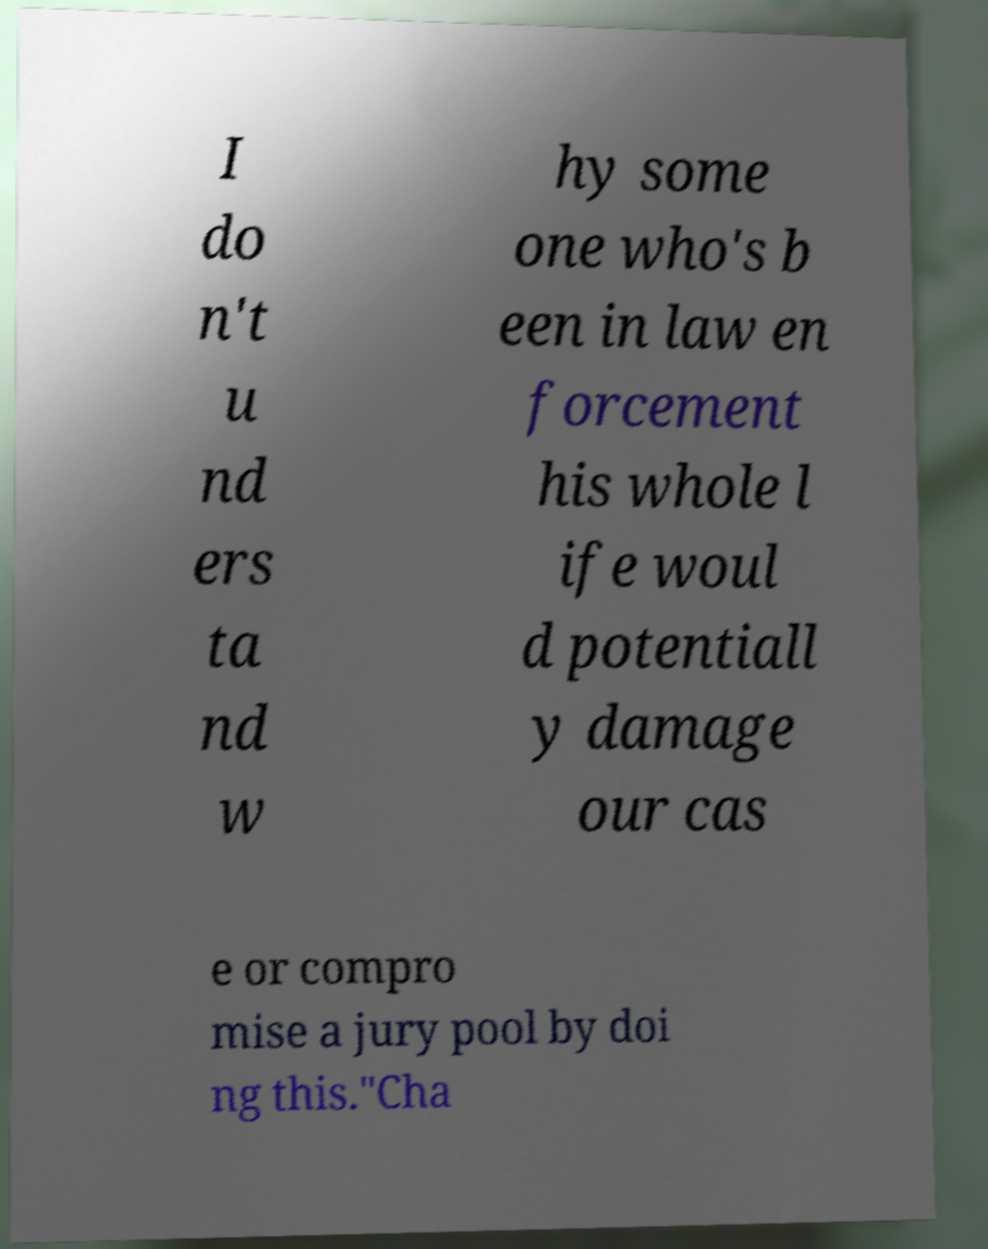I need the written content from this picture converted into text. Can you do that? I do n't u nd ers ta nd w hy some one who's b een in law en forcement his whole l ife woul d potentiall y damage our cas e or compro mise a jury pool by doi ng this."Cha 